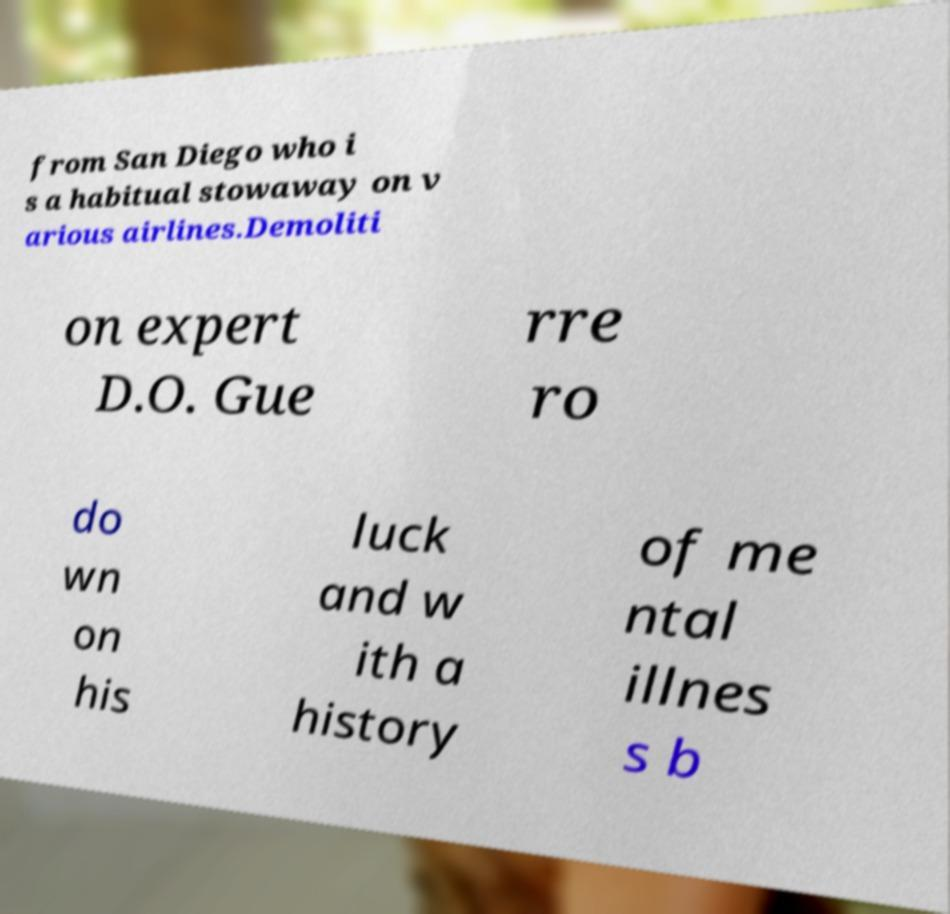For documentation purposes, I need the text within this image transcribed. Could you provide that? from San Diego who i s a habitual stowaway on v arious airlines.Demoliti on expert D.O. Gue rre ro do wn on his luck and w ith a history of me ntal illnes s b 